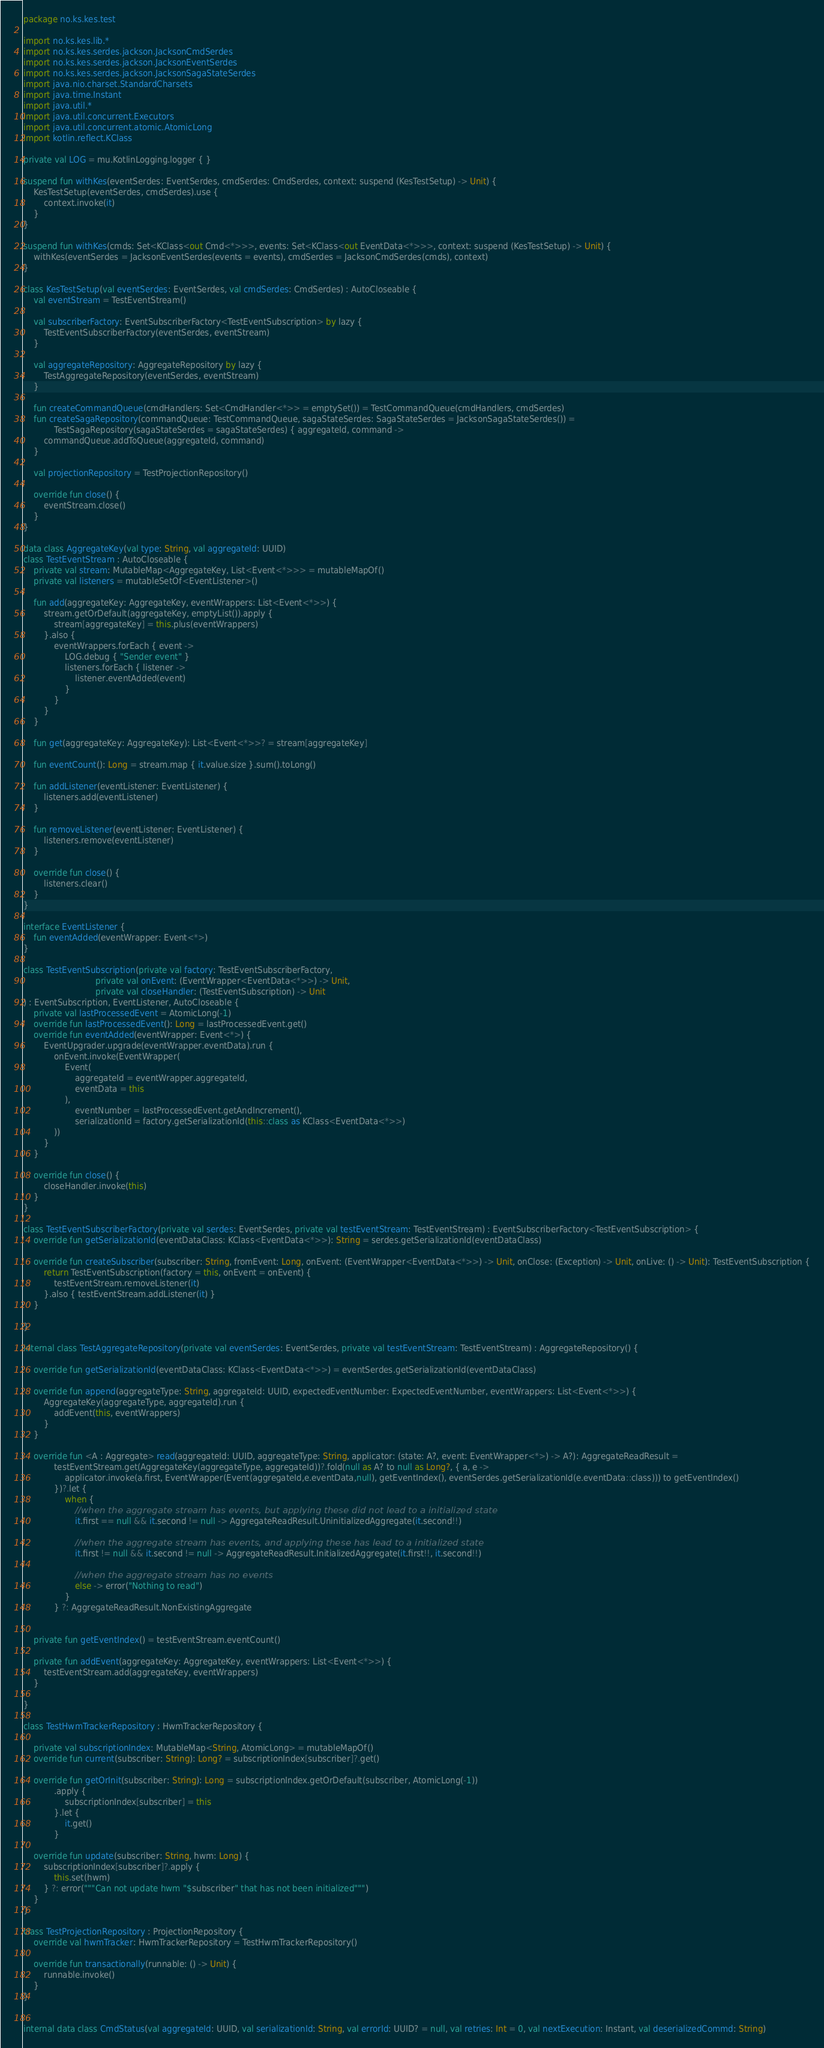Convert code to text. <code><loc_0><loc_0><loc_500><loc_500><_Kotlin_>package no.ks.kes.test

import no.ks.kes.lib.*
import no.ks.kes.serdes.jackson.JacksonCmdSerdes
import no.ks.kes.serdes.jackson.JacksonEventSerdes
import no.ks.kes.serdes.jackson.JacksonSagaStateSerdes
import java.nio.charset.StandardCharsets
import java.time.Instant
import java.util.*
import java.util.concurrent.Executors
import java.util.concurrent.atomic.AtomicLong
import kotlin.reflect.KClass

private val LOG = mu.KotlinLogging.logger { }

suspend fun withKes(eventSerdes: EventSerdes, cmdSerdes: CmdSerdes, context: suspend (KesTestSetup) -> Unit) {
    KesTestSetup(eventSerdes, cmdSerdes).use {
        context.invoke(it)
    }
}

suspend fun withKes(cmds: Set<KClass<out Cmd<*>>>, events: Set<KClass<out EventData<*>>>, context: suspend (KesTestSetup) -> Unit) {
    withKes(eventSerdes = JacksonEventSerdes(events = events), cmdSerdes = JacksonCmdSerdes(cmds), context)
}

class KesTestSetup(val eventSerdes: EventSerdes, val cmdSerdes: CmdSerdes) : AutoCloseable {
    val eventStream = TestEventStream()

    val subscriberFactory: EventSubscriberFactory<TestEventSubscription> by lazy {
        TestEventSubscriberFactory(eventSerdes, eventStream)
    }

    val aggregateRepository: AggregateRepository by lazy {
        TestAggregateRepository(eventSerdes, eventStream)
    }

    fun createCommandQueue(cmdHandlers: Set<CmdHandler<*>> = emptySet()) = TestCommandQueue(cmdHandlers, cmdSerdes)
    fun createSagaRepository(commandQueue: TestCommandQueue, sagaStateSerdes: SagaStateSerdes = JacksonSagaStateSerdes()) =
            TestSagaRepository(sagaStateSerdes = sagaStateSerdes) { aggregateId, command ->
        commandQueue.addToQueue(aggregateId, command)
    }

    val projectionRepository = TestProjectionRepository()

    override fun close() {
        eventStream.close()
    }
}

data class AggregateKey(val type: String, val aggregateId: UUID)
class TestEventStream : AutoCloseable {
    private val stream: MutableMap<AggregateKey, List<Event<*>>> = mutableMapOf()
    private val listeners = mutableSetOf<EventListener>()

    fun add(aggregateKey: AggregateKey, eventWrappers: List<Event<*>>) {
        stream.getOrDefault(aggregateKey, emptyList()).apply {
            stream[aggregateKey] = this.plus(eventWrappers)
        }.also {
            eventWrappers.forEach { event ->
                LOG.debug { "Sender event" }
                listeners.forEach { listener ->
                    listener.eventAdded(event)
                }
            }
        }
    }

    fun get(aggregateKey: AggregateKey): List<Event<*>>? = stream[aggregateKey]

    fun eventCount(): Long = stream.map { it.value.size }.sum().toLong()

    fun addListener(eventListener: EventListener) {
        listeners.add(eventListener)
    }

    fun removeListener(eventListener: EventListener) {
        listeners.remove(eventListener)
    }

    override fun close() {
        listeners.clear()
    }
}

interface EventListener {
    fun eventAdded(eventWrapper: Event<*>)
}

class TestEventSubscription(private val factory: TestEventSubscriberFactory,
                            private val onEvent: (EventWrapper<EventData<*>>) -> Unit,
                            private val closeHandler: (TestEventSubscription) -> Unit
) : EventSubscription, EventListener, AutoCloseable {
    private val lastProcessedEvent = AtomicLong(-1)
    override fun lastProcessedEvent(): Long = lastProcessedEvent.get()
    override fun eventAdded(eventWrapper: Event<*>) {
        EventUpgrader.upgrade(eventWrapper.eventData).run {
            onEvent.invoke(EventWrapper(
                Event(
                    aggregateId = eventWrapper.aggregateId,
                    eventData = this
                ),
                    eventNumber = lastProcessedEvent.getAndIncrement(),
                    serializationId = factory.getSerializationId(this::class as KClass<EventData<*>>)
            ))
        }
    }

    override fun close() {
        closeHandler.invoke(this)
    }
}

class TestEventSubscriberFactory(private val serdes: EventSerdes, private val testEventStream: TestEventStream) : EventSubscriberFactory<TestEventSubscription> {
    override fun getSerializationId(eventDataClass: KClass<EventData<*>>): String = serdes.getSerializationId(eventDataClass)

    override fun createSubscriber(subscriber: String, fromEvent: Long, onEvent: (EventWrapper<EventData<*>>) -> Unit, onClose: (Exception) -> Unit, onLive: () -> Unit): TestEventSubscription {
        return TestEventSubscription(factory = this, onEvent = onEvent) {
            testEventStream.removeListener(it)
        }.also { testEventStream.addListener(it) }
    }

}

internal class TestAggregateRepository(private val eventSerdes: EventSerdes, private val testEventStream: TestEventStream) : AggregateRepository() {

    override fun getSerializationId(eventDataClass: KClass<EventData<*>>) = eventSerdes.getSerializationId(eventDataClass)

    override fun append(aggregateType: String, aggregateId: UUID, expectedEventNumber: ExpectedEventNumber, eventWrappers: List<Event<*>>) {
        AggregateKey(aggregateType, aggregateId).run {
            addEvent(this, eventWrappers)
        }
    }

    override fun <A : Aggregate> read(aggregateId: UUID, aggregateType: String, applicator: (state: A?, event: EventWrapper<*>) -> A?): AggregateReadResult =
            testEventStream.get(AggregateKey(aggregateType, aggregateId))?.fold(null as A? to null as Long?, { a, e ->
                applicator.invoke(a.first, EventWrapper(Event(aggregateId,e.eventData,null), getEventIndex(), eventSerdes.getSerializationId(e.eventData::class))) to getEventIndex()
            })?.let {
                when {
                    //when the aggregate stream has events, but applying these did not lead to a initialized state
                    it.first == null && it.second != null -> AggregateReadResult.UninitializedAggregate(it.second!!)

                    //when the aggregate stream has events, and applying these has lead to a initialized state
                    it.first != null && it.second != null -> AggregateReadResult.InitializedAggregate(it.first!!, it.second!!)

                    //when the aggregate stream has no events
                    else -> error("Nothing to read")
                }
            } ?: AggregateReadResult.NonExistingAggregate


    private fun getEventIndex() = testEventStream.eventCount()

    private fun addEvent(aggregateKey: AggregateKey, eventWrappers: List<Event<*>>) {
        testEventStream.add(aggregateKey, eventWrappers)
    }

}

class TestHwmTrackerRepository : HwmTrackerRepository {

    private val subscriptionIndex: MutableMap<String, AtomicLong> = mutableMapOf()
    override fun current(subscriber: String): Long? = subscriptionIndex[subscriber]?.get()

    override fun getOrInit(subscriber: String): Long = subscriptionIndex.getOrDefault(subscriber, AtomicLong(-1))
            .apply {
                subscriptionIndex[subscriber] = this
            }.let {
                it.get()
            }

    override fun update(subscriber: String, hwm: Long) {
        subscriptionIndex[subscriber]?.apply {
            this.set(hwm)
        } ?: error("""Can not update hwm "$subscriber" that has not been initialized""")
    }
}

class TestProjectionRepository : ProjectionRepository {
    override val hwmTracker: HwmTrackerRepository = TestHwmTrackerRepository()

    override fun transactionally(runnable: () -> Unit) {
        runnable.invoke()
    }
}


internal data class CmdStatus(val aggregateId: UUID, val serializationId: String, val errorId: UUID? = null, val retries: Int = 0, val nextExecution: Instant, val deserializedCommd: String)</code> 